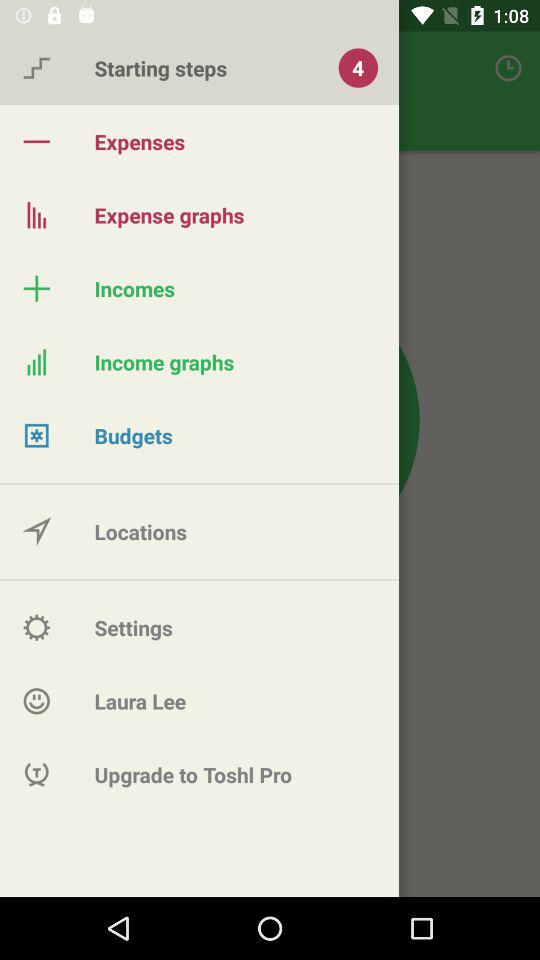What is the name of the user? The name of the user is Laura Lee. 